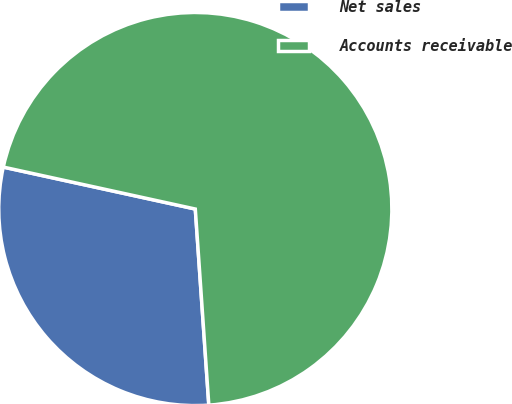Convert chart. <chart><loc_0><loc_0><loc_500><loc_500><pie_chart><fcel>Net sales<fcel>Accounts receivable<nl><fcel>29.52%<fcel>70.48%<nl></chart> 